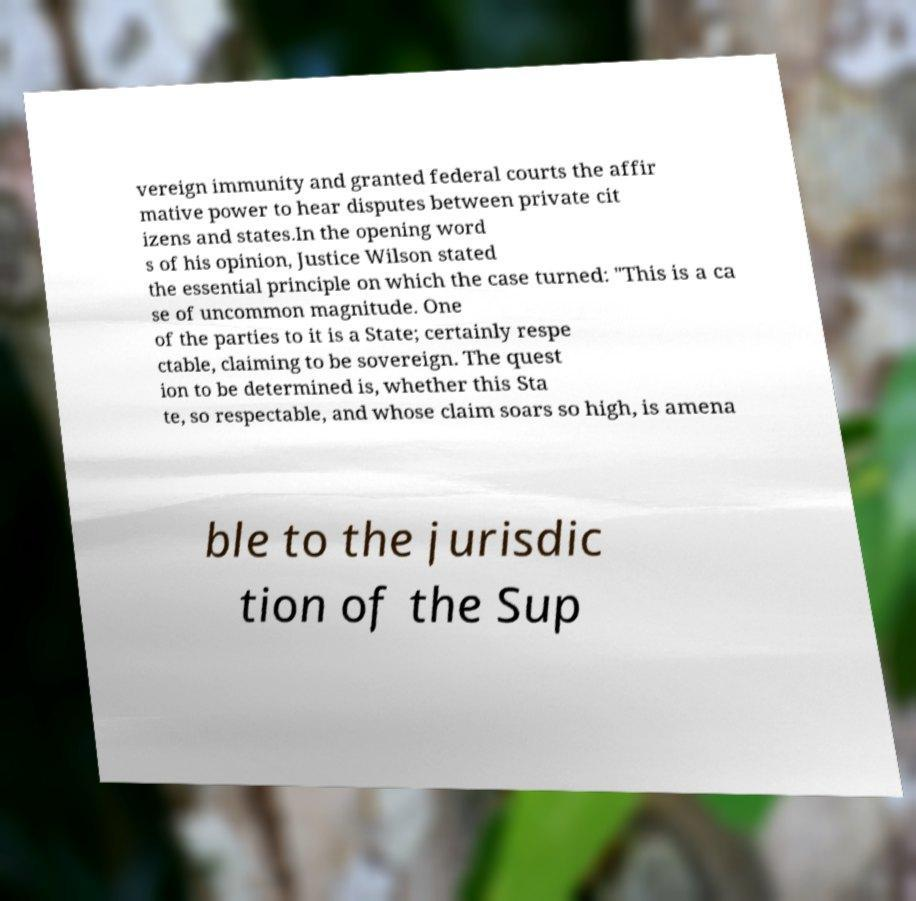Please identify and transcribe the text found in this image. vereign immunity and granted federal courts the affir mative power to hear disputes between private cit izens and states.In the opening word s of his opinion, Justice Wilson stated the essential principle on which the case turned: "This is a ca se of uncommon magnitude. One of the parties to it is a State; certainly respe ctable, claiming to be sovereign. The quest ion to be determined is, whether this Sta te, so respectable, and whose claim soars so high, is amena ble to the jurisdic tion of the Sup 